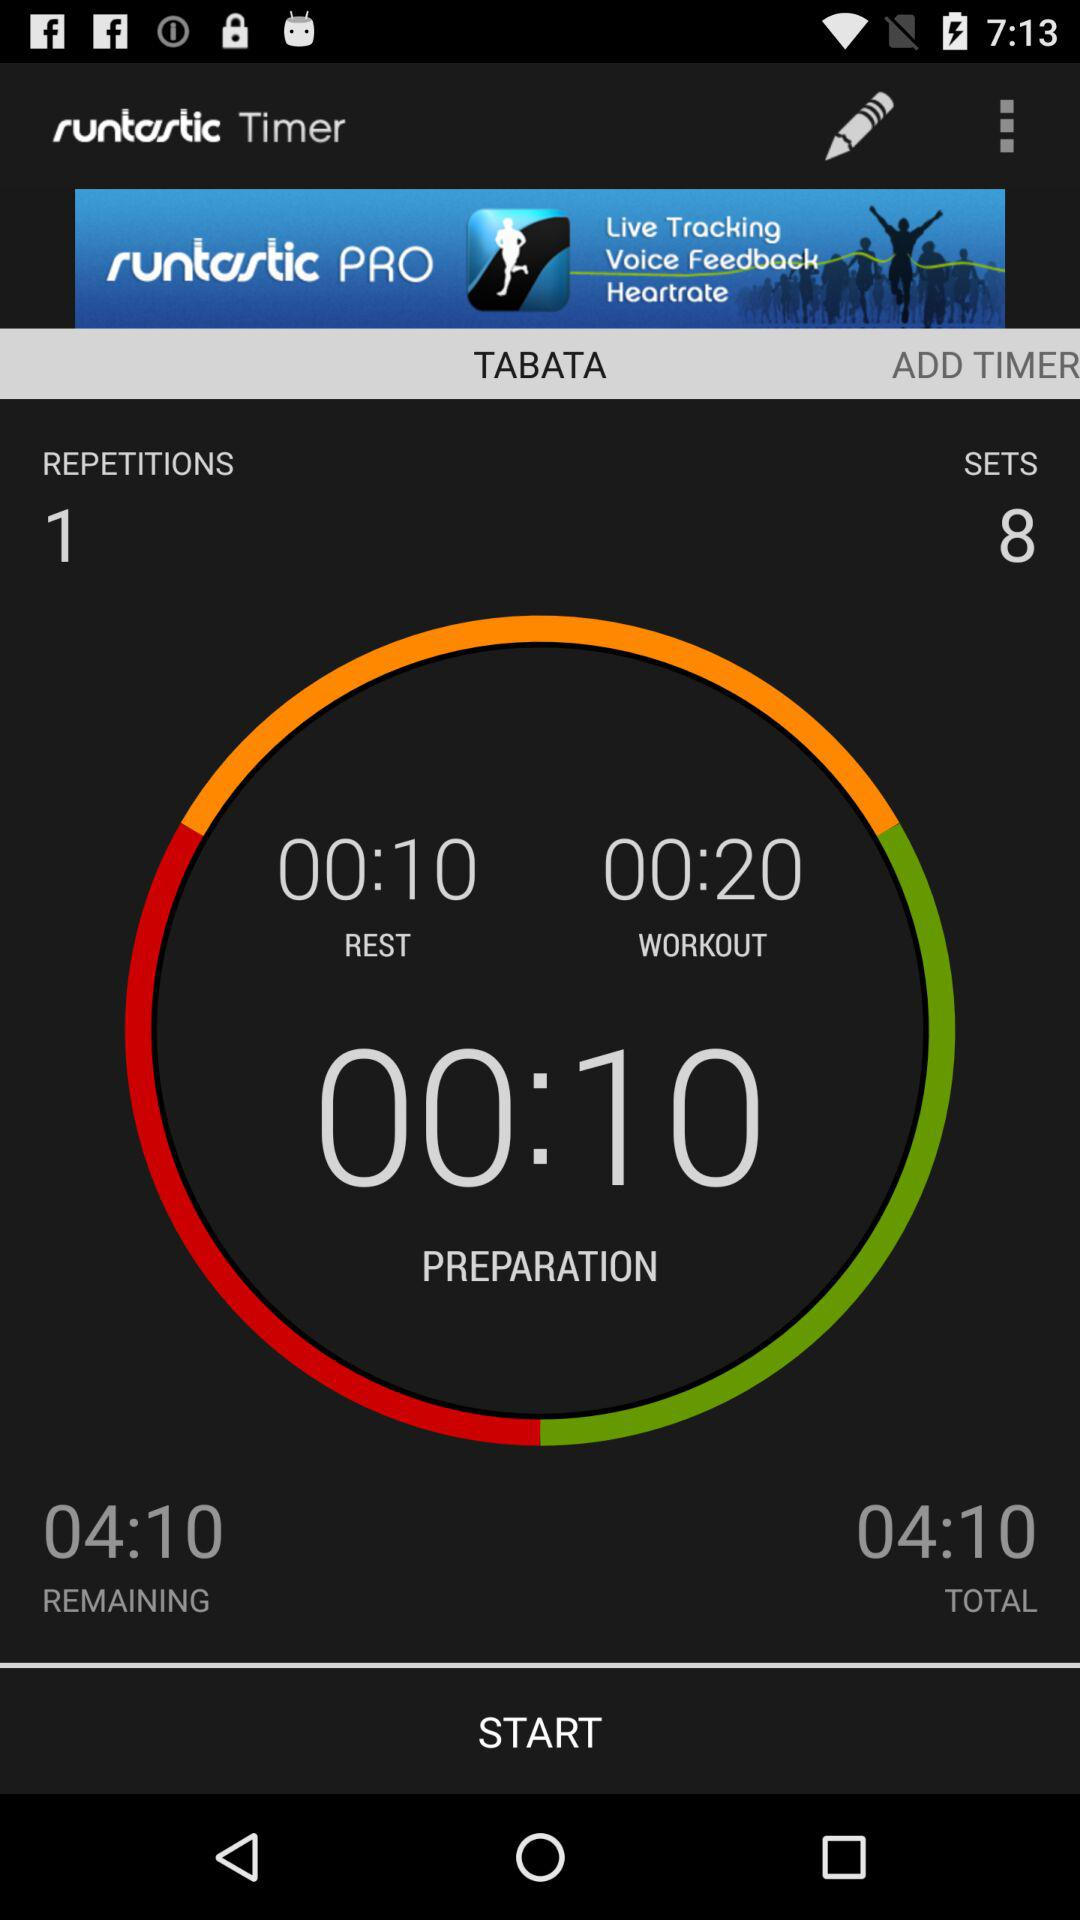How many sets are there in the timer?
Answer the question using a single word or phrase. 8 